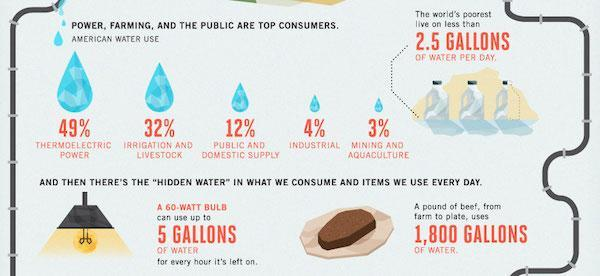How much water is used up by a 60W bulb if it is left on?
Answer the question with a short phrase. 5 gallons What is the per day water consumption by the world's poorest? 2.5 gallons Which sector is the second highest consumer of water? Irrigation and livestock What is the percentage of water consumption by the mining and aquaculture sector? 3% Which sector uses 12% of total water consumption? Public and domestic supply What is the percentage of water consumption by the industrial sector? 4% Which item that we consume uses 1,800 gallons of water? A pound of beef 